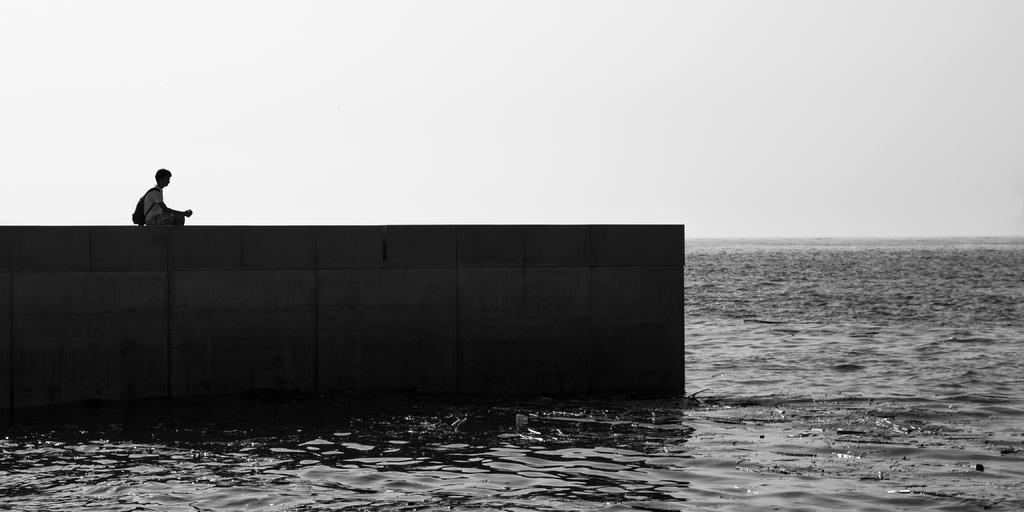Please provide a concise description of this image. This image is a black and white image. This image is taken outdoors. At the top of the image there is a sky. At the bottom of the image there is a sea. On the left side of the image there is a bridge and a boy is sitting on the bridge. 